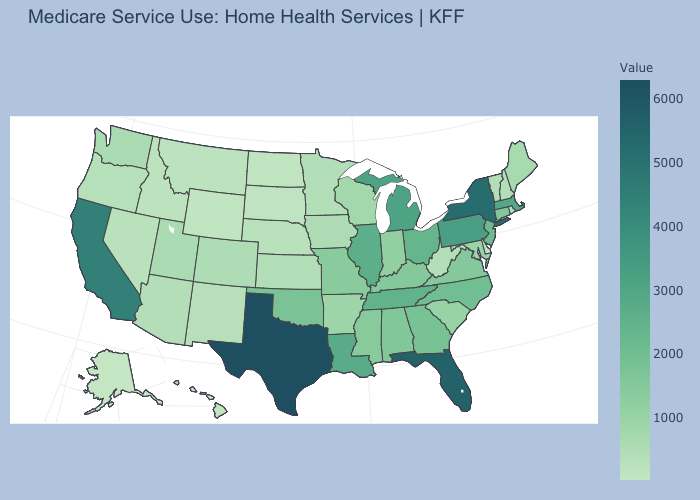Does New York have a lower value than Maryland?
Be succinct. No. Does the map have missing data?
Give a very brief answer. No. Among the states that border New Hampshire , which have the highest value?
Quick response, please. Massachusetts. 